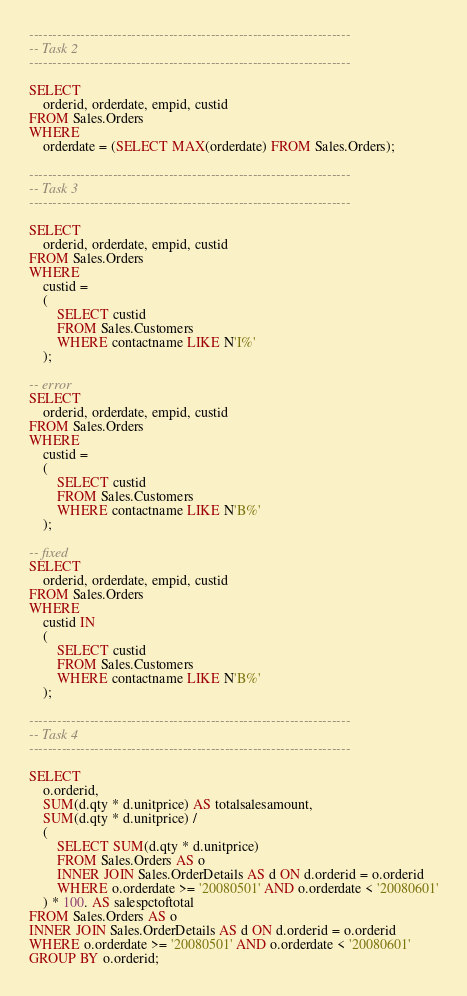Convert code to text. <code><loc_0><loc_0><loc_500><loc_500><_SQL_>---------------------------------------------------------------------
-- Task 2
---------------------------------------------------------------------

SELECT
	orderid, orderdate, empid, custid
FROM Sales.Orders
WHERE 
	orderdate = (SELECT MAX(orderdate) FROM Sales.Orders);

---------------------------------------------------------------------
-- Task 3
---------------------------------------------------------------------

SELECT
	orderid, orderdate, empid, custid
FROM Sales.Orders
WHERE 
	custid = 
	(
		SELECT custid
		FROM Sales.Customers
		WHERE contactname LIKE N'I%'
	);

-- error
SELECT
	orderid, orderdate, empid, custid
FROM Sales.Orders
WHERE 
	custid = 
	(
		SELECT custid
		FROM Sales.Customers
		WHERE contactname LIKE N'B%'
	);

-- fixed
SELECT
	orderid, orderdate, empid, custid
FROM Sales.Orders
WHERE 
	custid IN 
	(
		SELECT custid
		FROM Sales.Customers
		WHERE contactname LIKE N'B%'
	);

---------------------------------------------------------------------
-- Task 4
---------------------------------------------------------------------

SELECT
	o.orderid, 
	SUM(d.qty * d.unitprice) AS totalsalesamount,
	SUM(d.qty * d.unitprice) /
	(
		SELECT SUM(d.qty * d.unitprice) 
		FROM Sales.Orders AS o
		INNER JOIN Sales.OrderDetails AS d ON d.orderid = o.orderid
		WHERE o.orderdate >= '20080501' AND o.orderdate < '20080601'
	) * 100. AS salespctoftotal
FROM Sales.Orders AS o
INNER JOIN Sales.OrderDetails AS d ON d.orderid = o.orderid
WHERE o.orderdate >= '20080501' AND o.orderdate < '20080601'
GROUP BY o.orderid;




</code> 